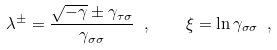<formula> <loc_0><loc_0><loc_500><loc_500>\lambda ^ { \pm } = \frac { \sqrt { - \gamma } \pm \gamma _ { \tau \sigma } } { \gamma _ { \sigma \sigma } } \ , \quad \xi = \ln \gamma _ { \sigma \sigma } \ ,</formula> 